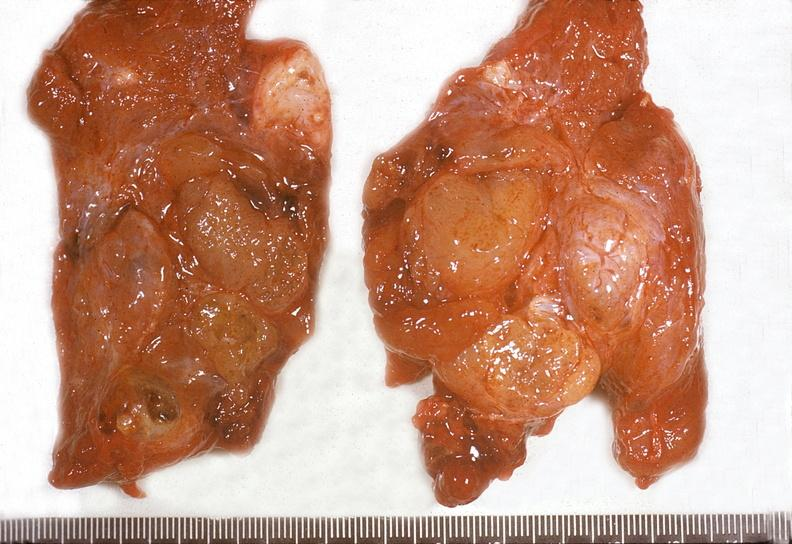what does this image show?
Answer the question using a single word or phrase. Thyroid 